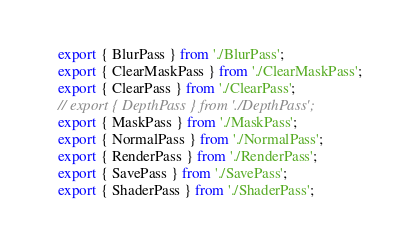Convert code to text. <code><loc_0><loc_0><loc_500><loc_500><_TypeScript_>export { BlurPass } from './BlurPass';
export { ClearMaskPass } from './ClearMaskPass';
export { ClearPass } from './ClearPass';
// export { DepthPass } from './DepthPass';
export { MaskPass } from './MaskPass';
export { NormalPass } from './NormalPass';
export { RenderPass } from './RenderPass';
export { SavePass } from './SavePass';
export { ShaderPass } from './ShaderPass';
</code> 